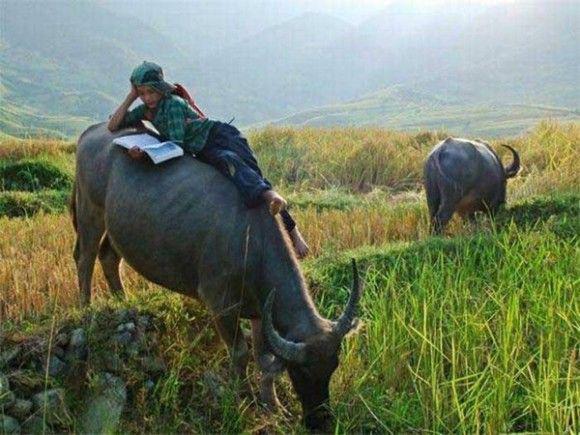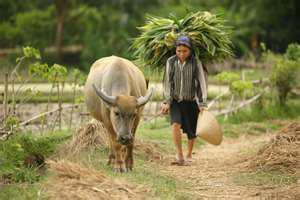The first image is the image on the left, the second image is the image on the right. Examine the images to the left and right. Is the description "One image shows only one person, who is wearing a cone-shaped hat and holding a stick, with at least one water buffalo standing in a wet area." accurate? Answer yes or no. No. The first image is the image on the left, the second image is the image on the right. For the images shown, is this caption "The left image contains two water buffaloes." true? Answer yes or no. Yes. 